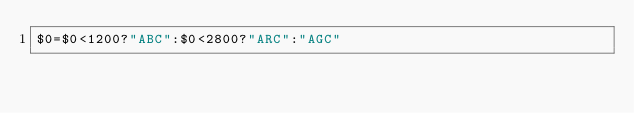Convert code to text. <code><loc_0><loc_0><loc_500><loc_500><_Awk_>$0=$0<1200?"ABC":$0<2800?"ARC":"AGC"</code> 